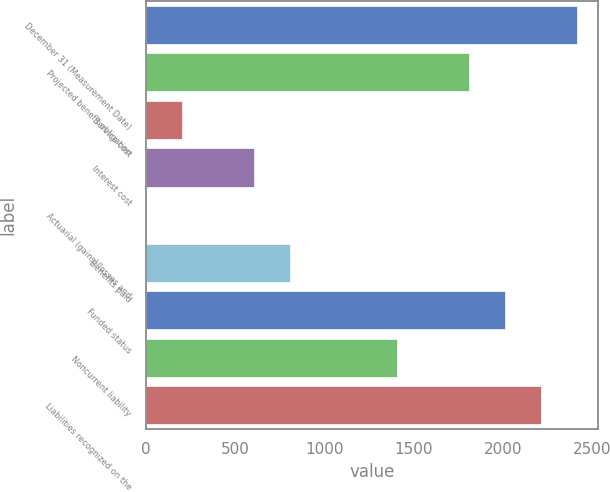Convert chart to OTSL. <chart><loc_0><loc_0><loc_500><loc_500><bar_chart><fcel>December 31 (Measurement Date)<fcel>Projected benefit obligation<fcel>Service cost<fcel>Interest cost<fcel>Actuarial (gains)/losses and<fcel>Benefits paid<fcel>Funded status<fcel>Noncurrent liability<fcel>Liabilities recognized on the<nl><fcel>2413<fcel>1810<fcel>202<fcel>604<fcel>1<fcel>805<fcel>2011<fcel>1408<fcel>2212<nl></chart> 